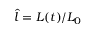Convert formula to latex. <formula><loc_0><loc_0><loc_500><loc_500>\hat { l } = L ( t ) / L _ { 0 }</formula> 